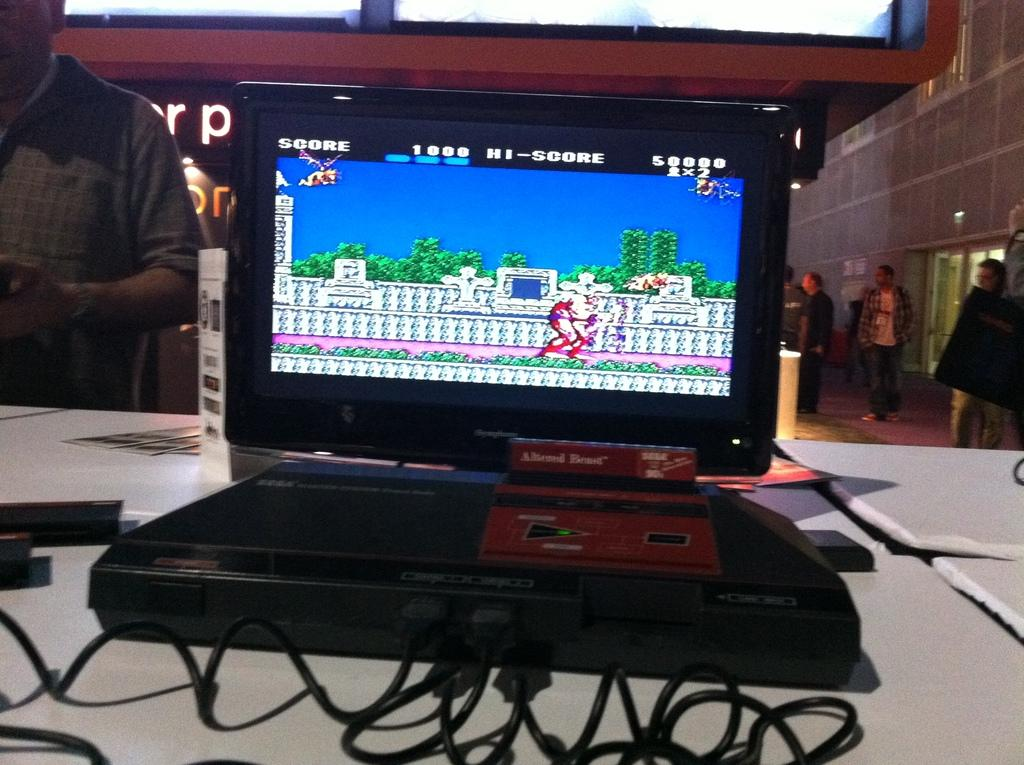Provide a one-sentence caption for the provided image. A console game displays the current score and high score at the top. 